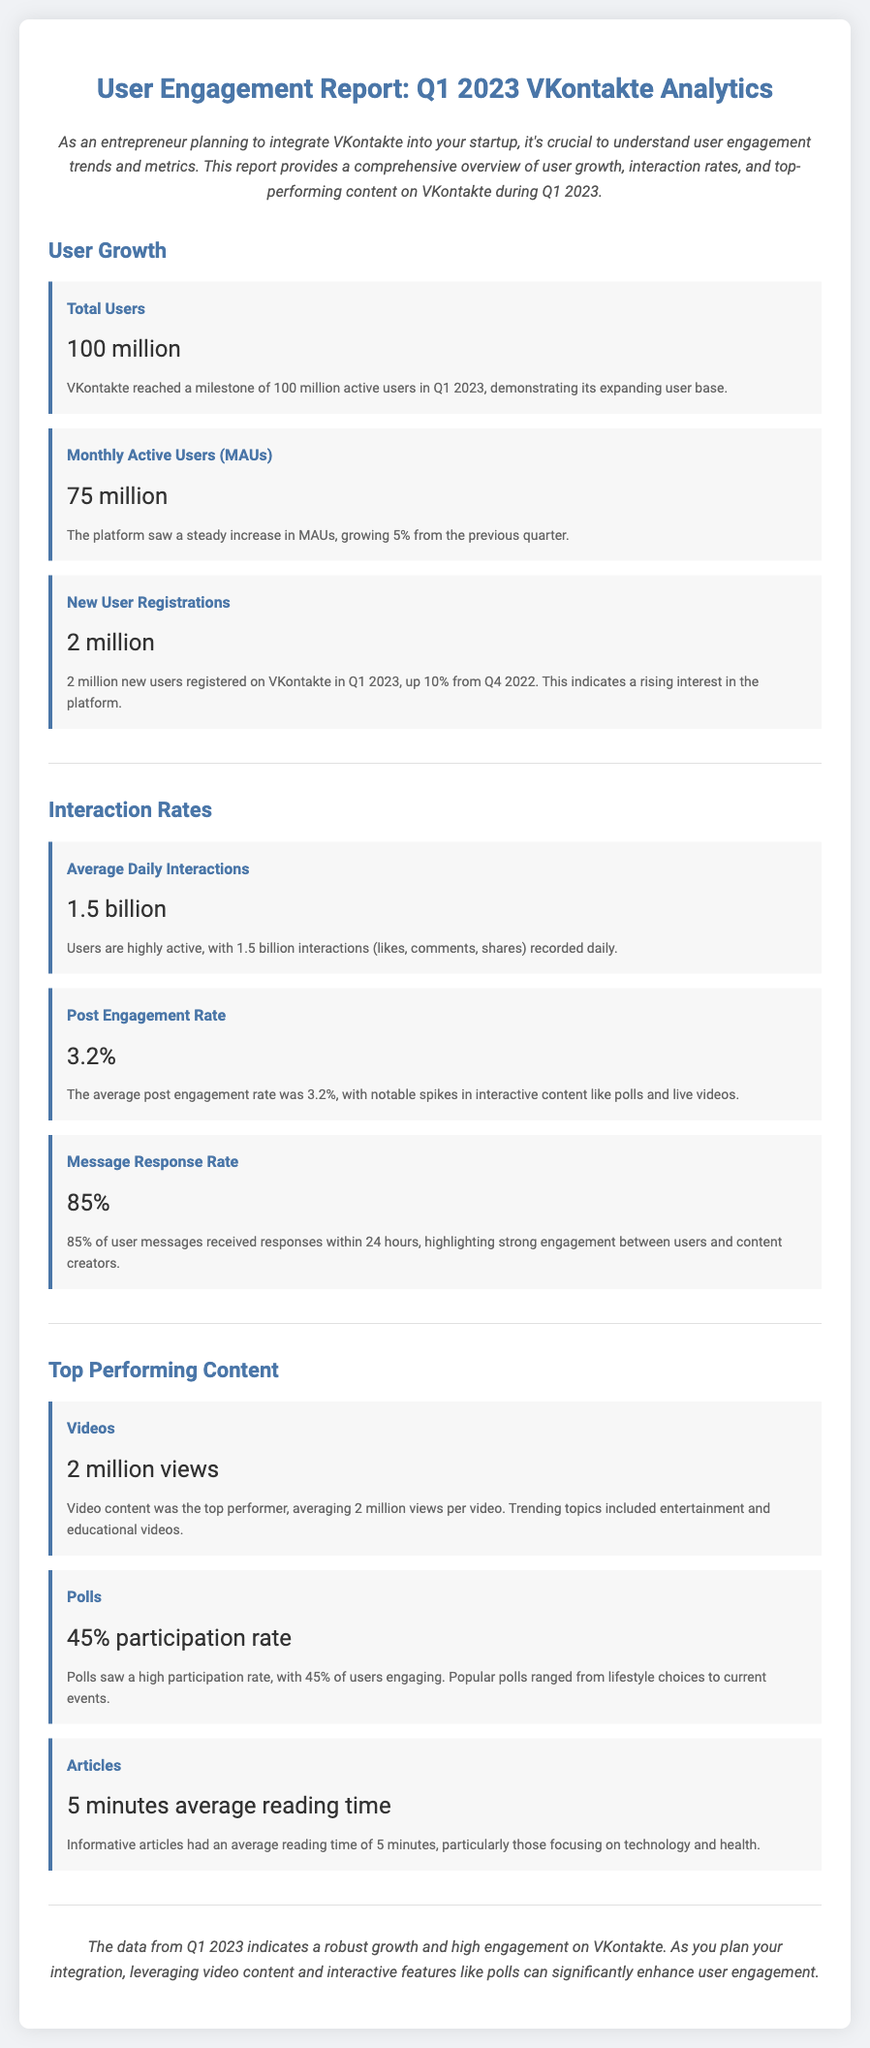What was the total number of users on VKontakte in Q1 2023? The total number of users is explicitly stated in the report, which mentions a milestone of 100 million users.
Answer: 100 million What is the percentage increase in new user registrations from Q4 2022 to Q1 2023? The report states that new user registrations increased by 10% from a previous quarter.
Answer: 10% What was the average daily interactions on the platform? The document specifies that the average daily interactions amounted to 1.5 billion.
Answer: 1.5 billion What content had the highest average views per video? According to the report, video content was the top performer with 2 million views per video.
Answer: 2 million views What was the message response rate within 24 hours? The document provides a precise figure of 85% for the message response rate within the specified timeframe.
Answer: 85% What was the average reading time for articles? The report mentions that informative articles had an average reading time of 5 minutes.
Answer: 5 minutes What metric indicates user engagement with polls? The participation rate for polls is highlighted, which is 45%, indicating user engagement.
Answer: 45% What was the post engagement rate in Q1 2023? The report notes that the post engagement rate was 3.2%.
Answer: 3.2% What was the primary topic for high-performing video content? The document mentions that trending topics for videos included entertainment and educational content.
Answer: Entertainment and educational videos 